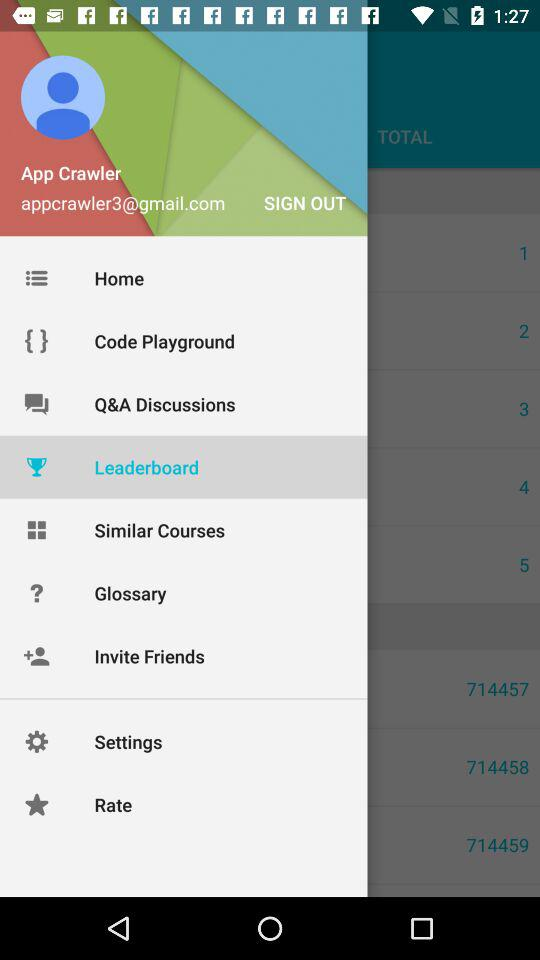Who is ranked #1 on the leader board?
When the provided information is insufficient, respond with <no answer>. <no answer> 